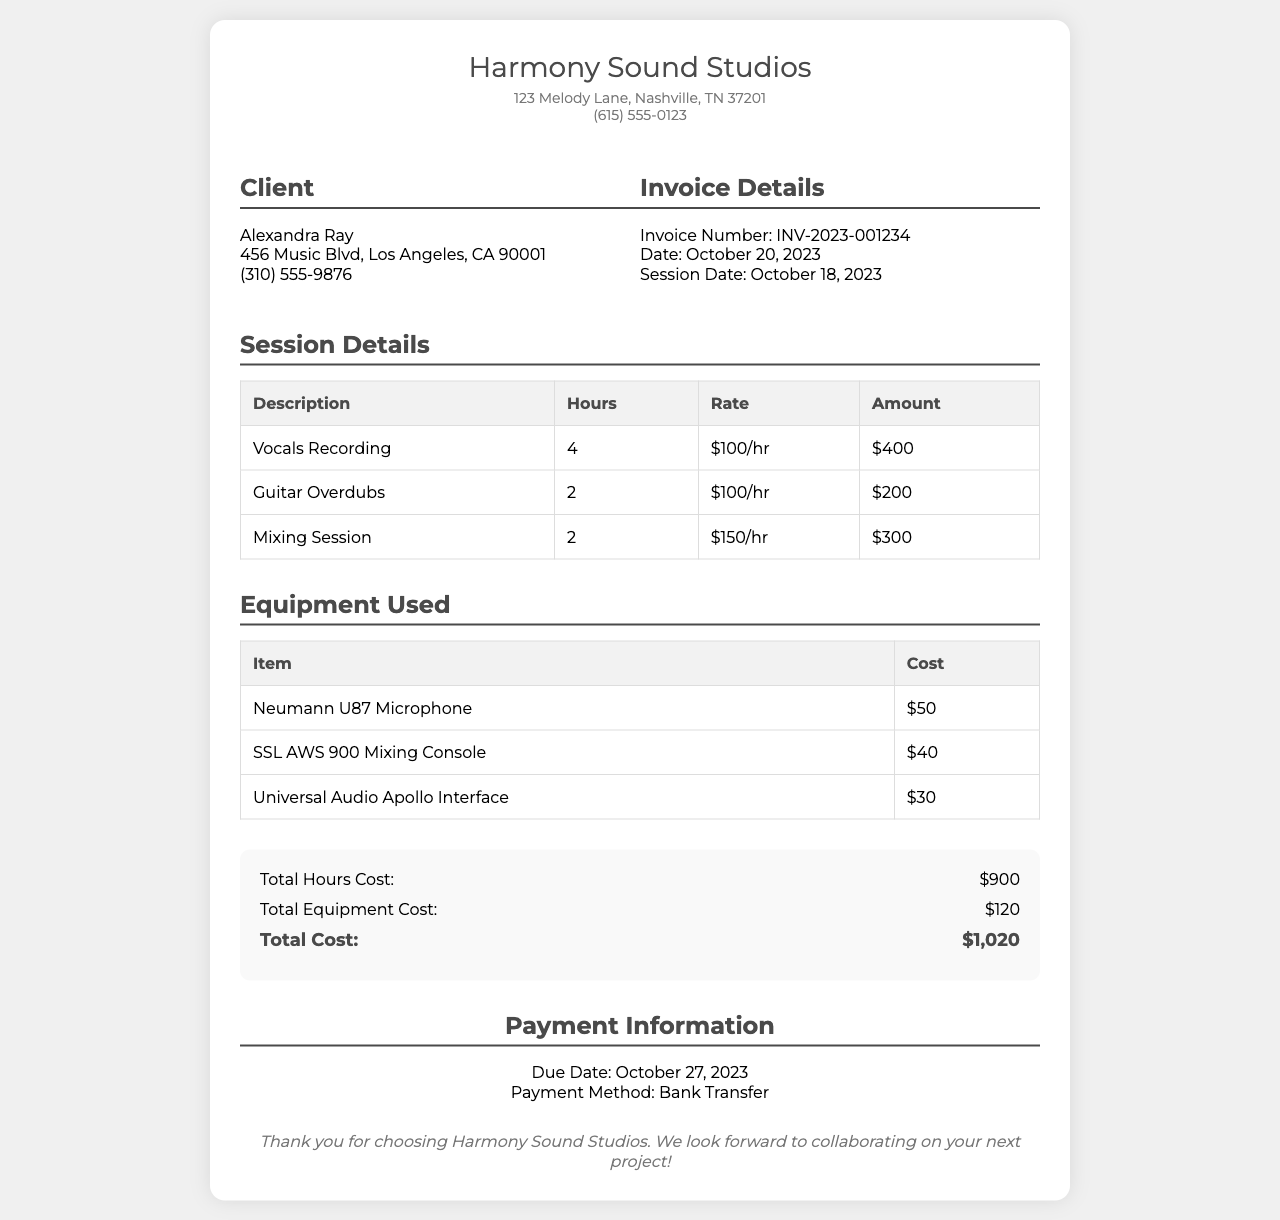What is the invoice number? The invoice number is listed under Invoice Details in the document.
Answer: INV-2023-001234 What is the total cost for the session? The total cost is calculated from the total hours cost and total equipment cost in the summary section.
Answer: $1,020 How many hours were spent on Vocal Recording? The number of hours spent on Vocal Recording is detailed in the Session Details table.
Answer: 4 What is the cost of the Neumann U87 Microphone? The cost of the Neumann U87 Microphone is provided in the Equipment Used section.
Answer: $50 On what date was the session conducted? The session date can be found in the Invoice Details section.
Answer: October 18, 2023 What is the payment method mentioned in the document? The payment method is specified in the Payment Information section.
Answer: Bank Transfer How many total hours were billed? The total hours billed can be calculated by summing the hours listed in the Session Details table.
Answer: 8 What is the due date for the payment? The due date is mentioned in the Payment Information section.
Answer: October 27, 2023 What is the rate for mixing sessions? The rate for mixing sessions is listed in the Session Details table alongside the number of hours.
Answer: $150/hr 